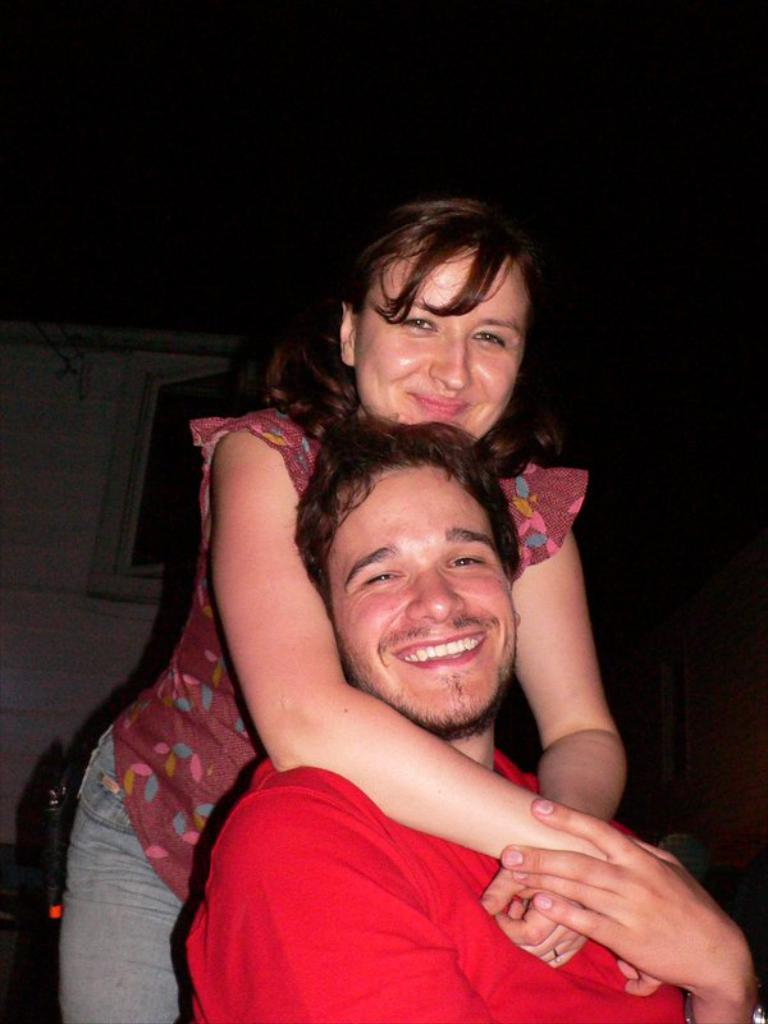How many people are in the image? There are two people in the image. What are the people wearing in the image? The two people are wearing dresses with different colors. What is the color of the background in the image? The background of the image is black. Can you see any clouds in the image? There are no clouds visible in the image, as the background is black. What type of power source is being used by the people in the image? There is no indication of any power source being used by the people in the image. 